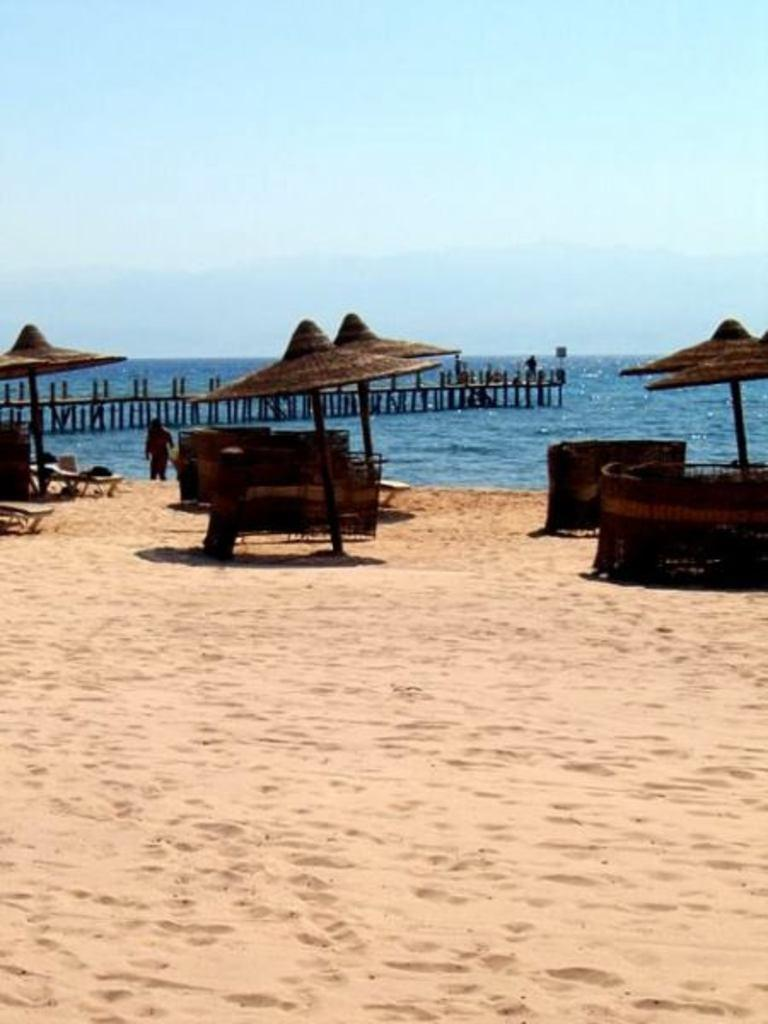What objects can be seen in the image? There are umbrellas and chairs in the image. What is the person in the image standing on? The person is standing on sand in the image. Can you describe the background of the image? There are two people standing on a path, water is visible, and the sky is visible in the background of the image. What type of friction can be observed between the person and the sand in the image? There is no friction mentioned or observable in the image; it simply shows a person standing on sand. How many crows are visible in the image? There are no crows present in the image. 